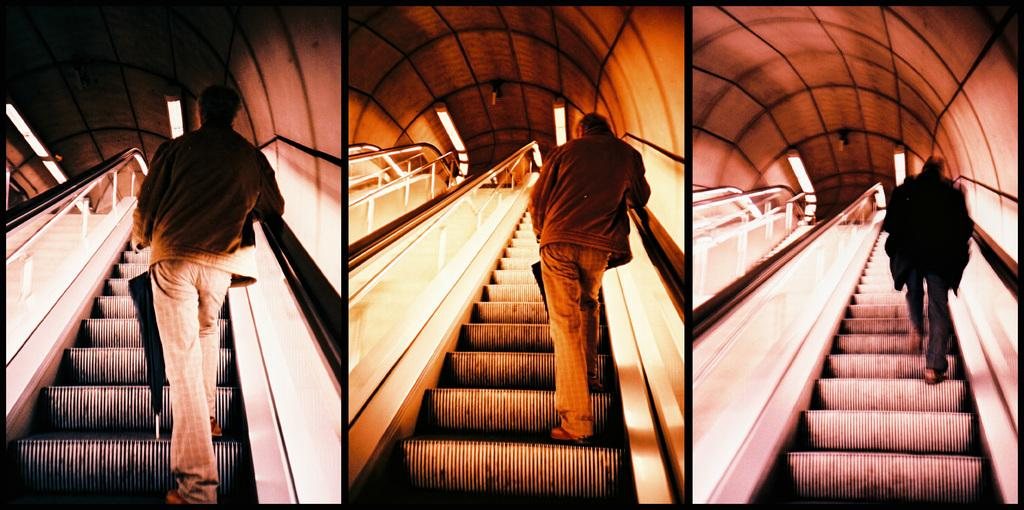What is the person in the image doing? The person is standing on an escalator in one of the images. What can be seen at the top of the escalator? There are lights on the top of the escalator in one of the images. How many rabbits are hopping on the escalator in the image? There are no rabbits present in the image; it features a person standing on an escalator. What type of chain is used to secure the escalator in the image? There is no chain visible in the image; it only shows a person standing on an escalator and lights at the top. 